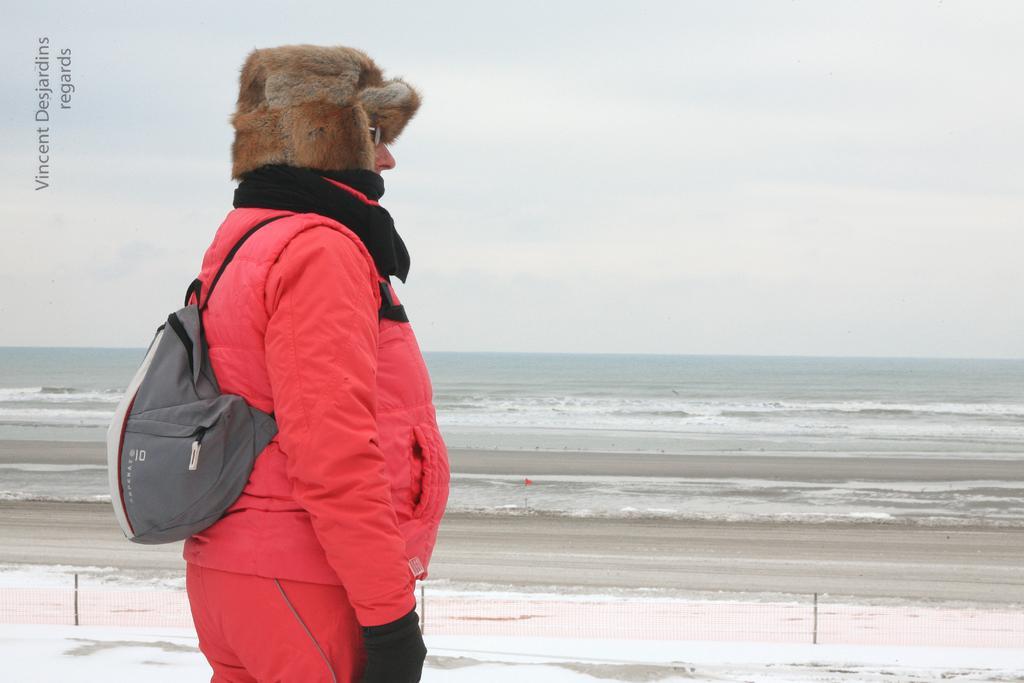How would you summarize this image in a sentence or two? In this image we can see a person wearing cap, specs, gloves and a bag. In the back there is water and sky. And there is a watermark in the right top corner. 